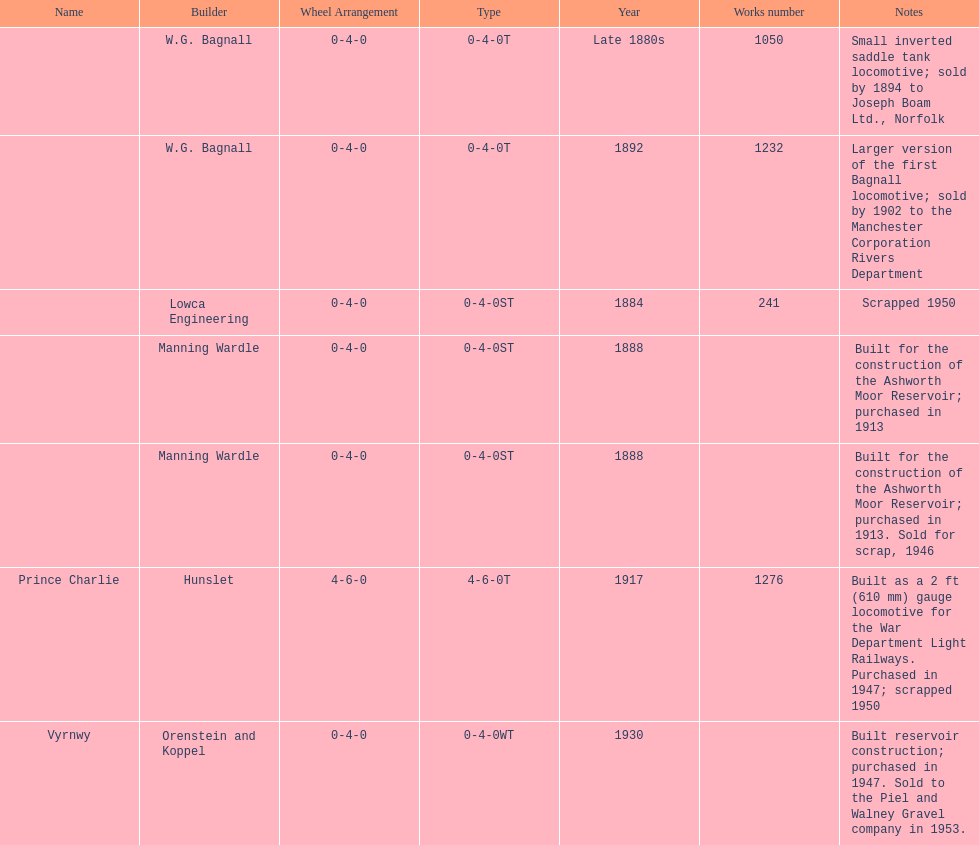Which locomotive builder built a locomotive after 1888 and built the locomotive as a 2ft gauge locomotive? Hunslet. 